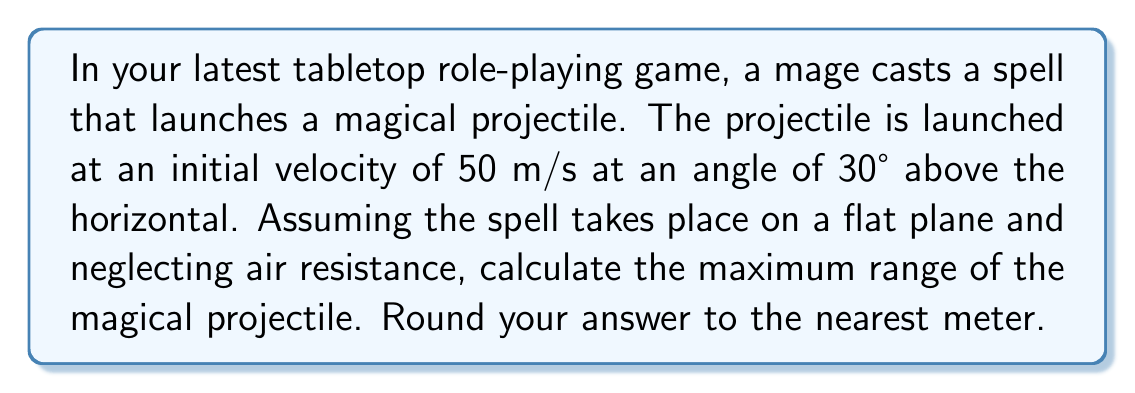Show me your answer to this math problem. To solve this problem, we'll use the range equation from projectile motion in physics. The range equation is:

$$R = \frac{v_0^2 \sin(2\theta)}{g}$$

Where:
$R$ = range (horizontal distance traveled)
$v_0$ = initial velocity
$\theta$ = launch angle
$g$ = acceleration due to gravity (9.8 m/s²)

Let's plug in our values:
$v_0 = 50$ m/s
$\theta = 30°$
$g = 9.8$ m/s²

First, we need to calculate $\sin(2\theta)$:
$2\theta = 2 * 30° = 60°$
$\sin(60°) = \frac{\sqrt{3}}{2}$

Now we can substitute these values into our equation:

$$R = \frac{(50 \text{ m/s})^2 * \frac{\sqrt{3}}{2}}{9.8 \text{ m/s}^2}$$

$$R = \frac{2500 \text{ m}^2 * \frac{\sqrt{3}}{2}}{9.8 \text{ m/s}^2}$$

$$R = \frac{2500 * \sqrt{3}}{2 * 9.8} \text{ m}$$

$$R \approx 220.8 \text{ m}$$

Rounding to the nearest meter, we get 221 meters.
Answer: 221 meters 